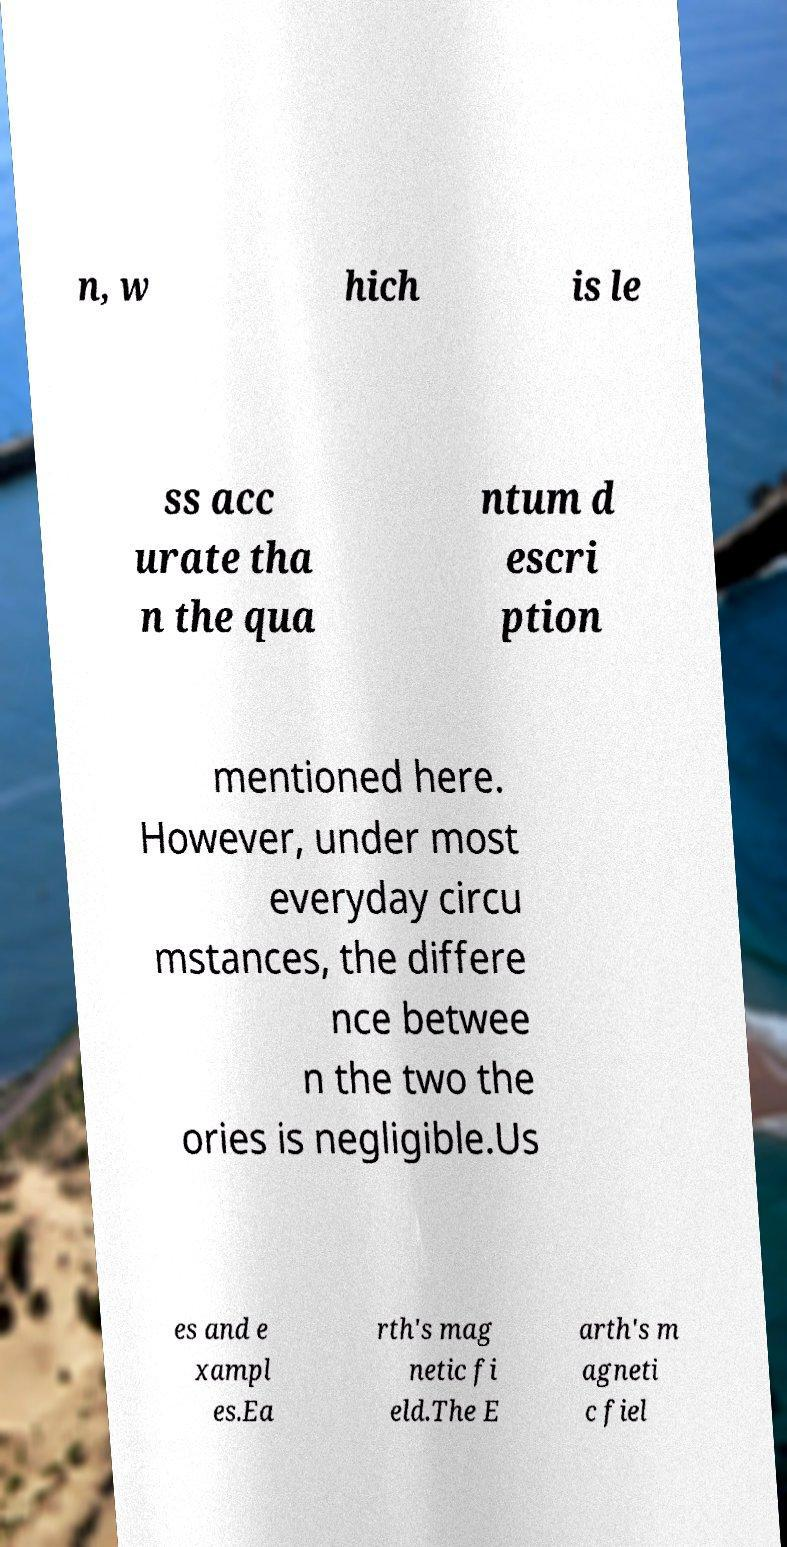Can you read and provide the text displayed in the image?This photo seems to have some interesting text. Can you extract and type it out for me? n, w hich is le ss acc urate tha n the qua ntum d escri ption mentioned here. However, under most everyday circu mstances, the differe nce betwee n the two the ories is negligible.Us es and e xampl es.Ea rth's mag netic fi eld.The E arth's m agneti c fiel 